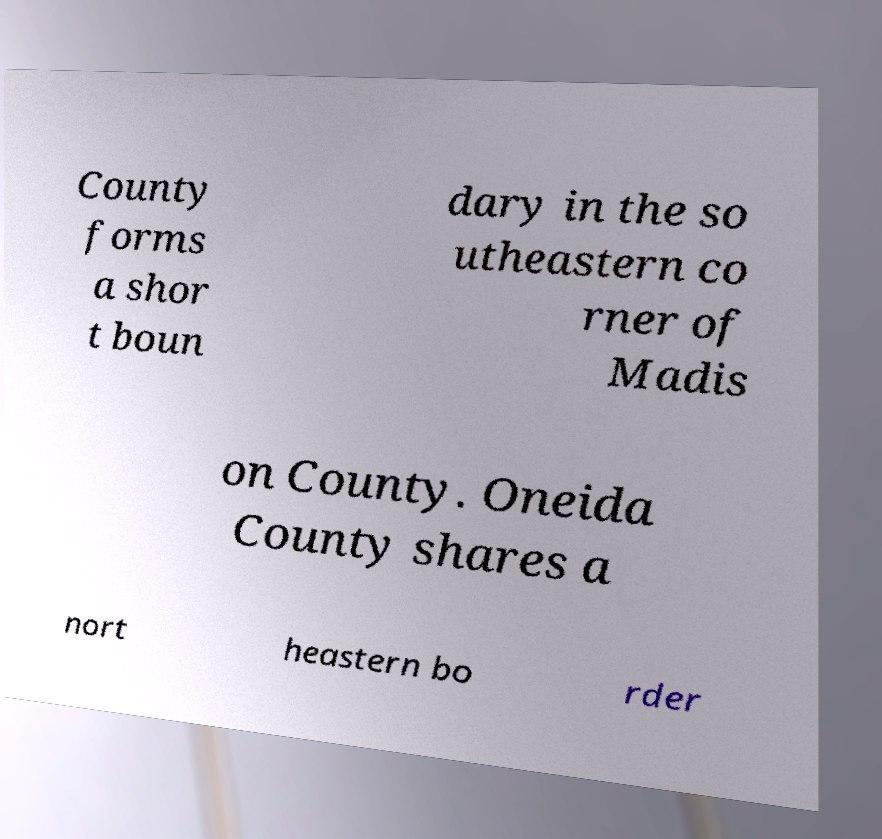Could you assist in decoding the text presented in this image and type it out clearly? County forms a shor t boun dary in the so utheastern co rner of Madis on County. Oneida County shares a nort heastern bo rder 